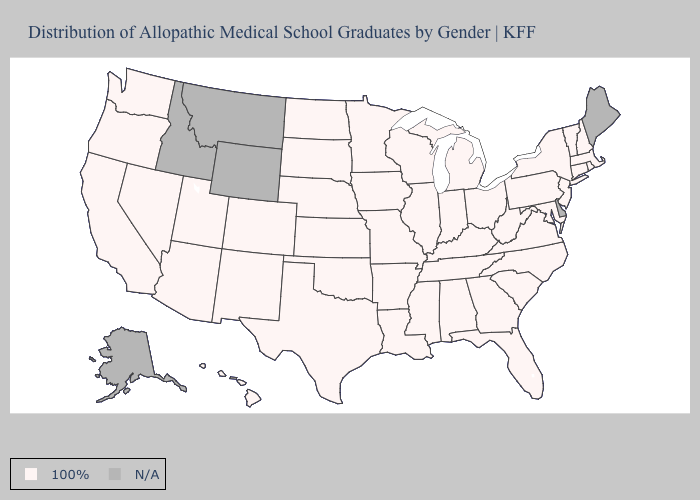Name the states that have a value in the range 100%?
Write a very short answer. Alabama, Arizona, Arkansas, California, Colorado, Connecticut, Florida, Georgia, Hawaii, Illinois, Indiana, Iowa, Kansas, Kentucky, Louisiana, Maryland, Massachusetts, Michigan, Minnesota, Mississippi, Missouri, Nebraska, Nevada, New Hampshire, New Jersey, New Mexico, New York, North Carolina, North Dakota, Ohio, Oklahoma, Oregon, Pennsylvania, Rhode Island, South Carolina, South Dakota, Tennessee, Texas, Utah, Vermont, Virginia, Washington, West Virginia, Wisconsin. Does the map have missing data?
Concise answer only. Yes. How many symbols are there in the legend?
Keep it brief. 2. What is the highest value in the Northeast ?
Write a very short answer. 100%. What is the value of Arizona?
Answer briefly. 100%. What is the highest value in the USA?
Short answer required. 100%. Name the states that have a value in the range N/A?
Short answer required. Alaska, Delaware, Idaho, Maine, Montana, Wyoming. Name the states that have a value in the range 100%?
Concise answer only. Alabama, Arizona, Arkansas, California, Colorado, Connecticut, Florida, Georgia, Hawaii, Illinois, Indiana, Iowa, Kansas, Kentucky, Louisiana, Maryland, Massachusetts, Michigan, Minnesota, Mississippi, Missouri, Nebraska, Nevada, New Hampshire, New Jersey, New Mexico, New York, North Carolina, North Dakota, Ohio, Oklahoma, Oregon, Pennsylvania, Rhode Island, South Carolina, South Dakota, Tennessee, Texas, Utah, Vermont, Virginia, Washington, West Virginia, Wisconsin. Does the map have missing data?
Be succinct. Yes. What is the value of Iowa?
Answer briefly. 100%. 